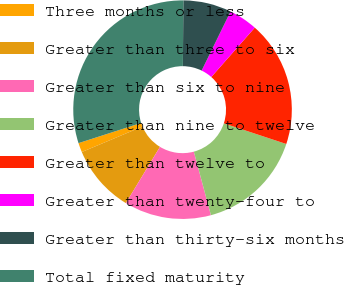Convert chart to OTSL. <chart><loc_0><loc_0><loc_500><loc_500><pie_chart><fcel>Three months or less<fcel>Greater than three to six<fcel>Greater than six to nine<fcel>Greater than nine to twelve<fcel>Greater than twelve to<fcel>Greater than twenty-four to<fcel>Greater than thirty-six months<fcel>Total fixed maturity<nl><fcel>1.38%<fcel>9.99%<fcel>12.86%<fcel>15.73%<fcel>18.6%<fcel>4.25%<fcel>7.12%<fcel>30.08%<nl></chart> 